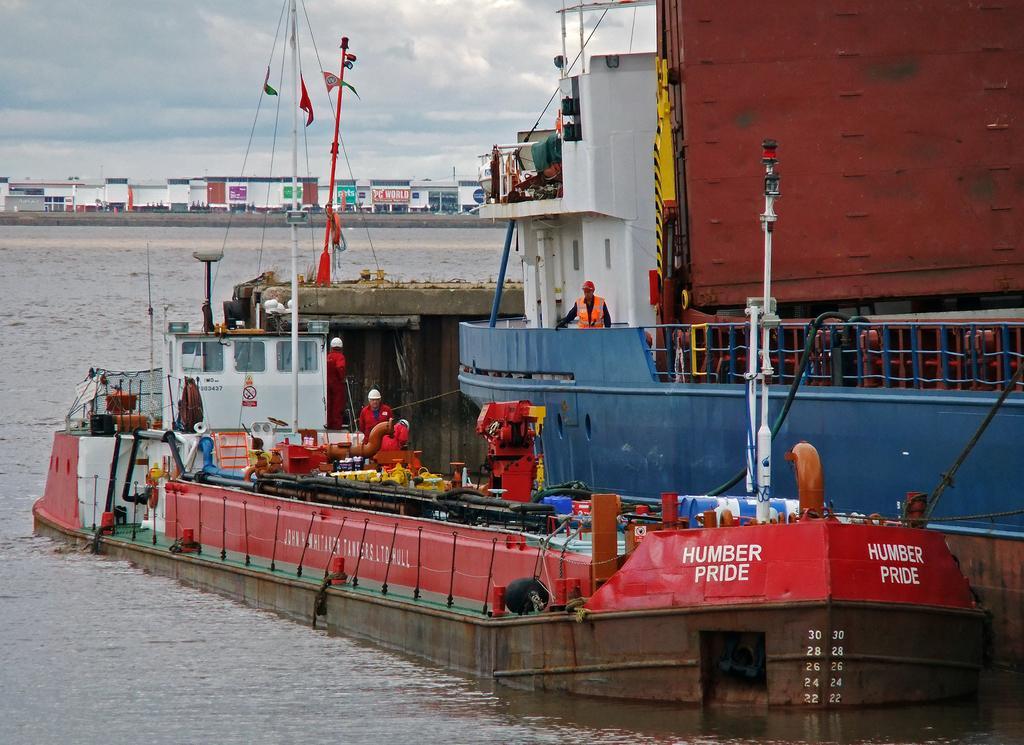How would you summarize this image in a sentence or two? In this image there is a ship at right side of this image and there is one person standing at right side of this image is wearing yellow color jacket, and there is a pole in white color at right side of this image. There is a boat in below of this image and there is a text written on it in white color at right side of this image. There are some more persons in middle of this image is wearing white color helmet. there is a water at bottom of this image and middle of this image. There are some buildings in the background and there is a sky at top of this image. 